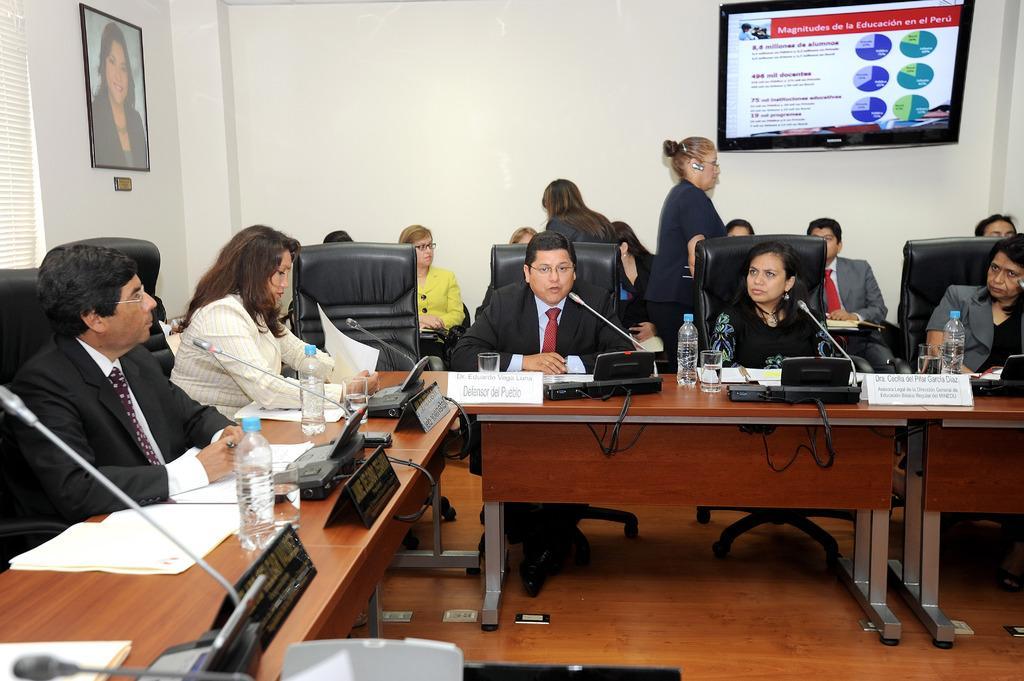Describe this image in one or two sentences. The picture is clicked inside a conference hall with several delegates sitting a black chair. In the background we observe a photo frame and an LCD attached to the wall. 